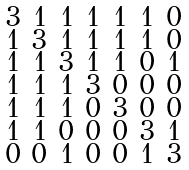<formula> <loc_0><loc_0><loc_500><loc_500>\begin{smallmatrix} 3 & 1 & 1 & 1 & 1 & 1 & 0 \\ 1 & 3 & 1 & 1 & 1 & 1 & 0 \\ 1 & 1 & 3 & 1 & 1 & 0 & 1 \\ 1 & 1 & 1 & 3 & 0 & 0 & 0 \\ 1 & 1 & 1 & 0 & 3 & 0 & 0 \\ 1 & 1 & 0 & 0 & 0 & 3 & 1 \\ 0 & 0 & 1 & 0 & 0 & 1 & 3 \end{smallmatrix}</formula> 